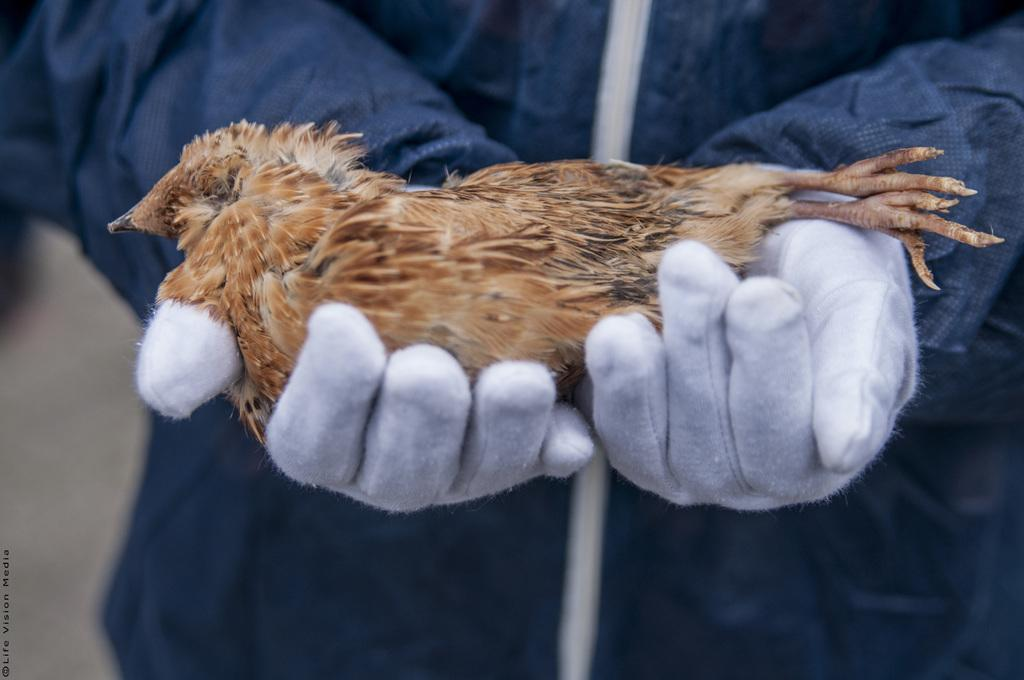What is present in the image? There is a person in the image. What type of clothing is the person wearing? The person is wearing a jacket. What type of accessory is the person wearing? The person is wearing gloves. What is the person holding in the image? The person is holding a bird. What type of connection can be seen between the person and the bird in the image? There is no visible connection between the person and the bird in the image; the person is simply holding the bird. What type of song is the bird singing in the image? There is no indication in the image that the bird is singing, nor is there any information about the type of song it might be singing. 